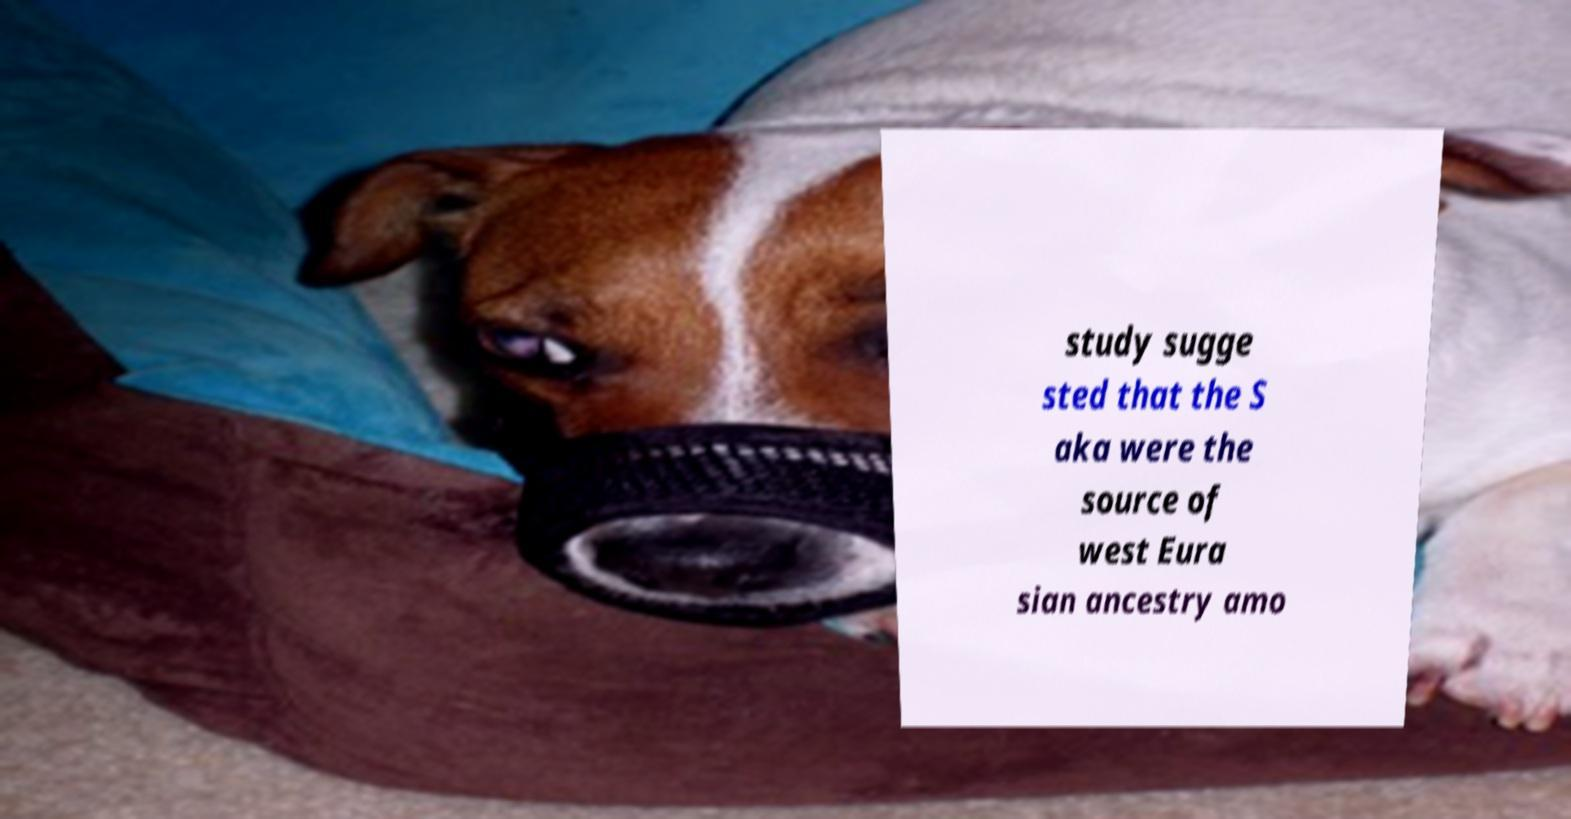Can you accurately transcribe the text from the provided image for me? study sugge sted that the S aka were the source of west Eura sian ancestry amo 